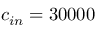<formula> <loc_0><loc_0><loc_500><loc_500>c _ { i n } = 3 0 0 0 0</formula> 